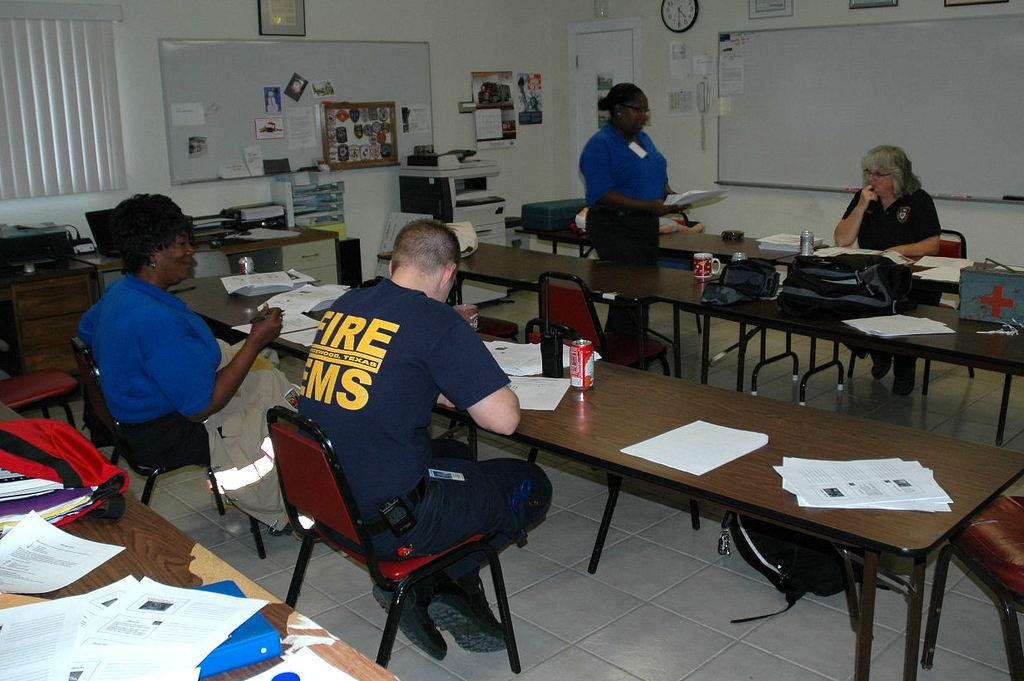What is the person in the image doing? The person is sitting on a chair in the image. Where is the chair located in relation to the table? The chair is near a table in the image. What items can be seen on the table? Papers and a bottle are on the table in the image. What is hanging on the wall? There is a clock and posters on the wall in the image. What is in the vicinity of the door? An xerox machine is near the door in the image. What object is present in the area that might be used for carrying items? There is a bag in the area in the image. What language are the person's toes speaking in the image? There are no visible toes in the image, and toes cannot speak any language. 